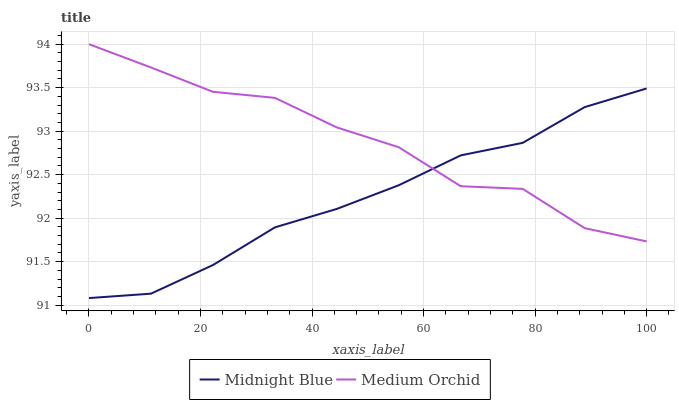Does Midnight Blue have the minimum area under the curve?
Answer yes or no. Yes. Does Medium Orchid have the maximum area under the curve?
Answer yes or no. Yes. Does Midnight Blue have the maximum area under the curve?
Answer yes or no. No. Is Midnight Blue the smoothest?
Answer yes or no. Yes. Is Medium Orchid the roughest?
Answer yes or no. Yes. Is Midnight Blue the roughest?
Answer yes or no. No. Does Midnight Blue have the lowest value?
Answer yes or no. Yes. Does Medium Orchid have the highest value?
Answer yes or no. Yes. Does Midnight Blue have the highest value?
Answer yes or no. No. Does Midnight Blue intersect Medium Orchid?
Answer yes or no. Yes. Is Midnight Blue less than Medium Orchid?
Answer yes or no. No. Is Midnight Blue greater than Medium Orchid?
Answer yes or no. No. 